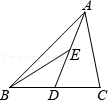How does the concept of midpoints help in simplifying calculations in other complex geometric shapes? The use of midpoints plays a crucial role in simplifying calculations across a range of geometric shapes. In polygons, identifying midpoints can help decompose a complex shape into simpler, manageable parts, making it easier to compute areas and perimeters. For instance, in polygons like hexagons or pentagons, drawing diagonals from midpoints can divide the figure into triangles or trapezoids, where standard geometric formulas can be more readily applied. This strategy reduces the overall complexity and encourages a modular approach to tackling geometry problems. Could you explain how this midpoint technique could be practically applied in a real-world scenario? Certainly! Consider a land surveyor tasked with determining the area of a particularly irregular plot of land. By identifying strategic midpoints along the boundaries of the plot and connecting these with straight lines to form triangles and trapezoids, the surveyor can break down the irregular shape into regular forms. Each section's area can then be calculated easily with basic geometric formulas. This method not only provides accuracy but also efficiency, crucial in scenarios where quick and reliable measurements are needed, like in construction planning or landscape design. 